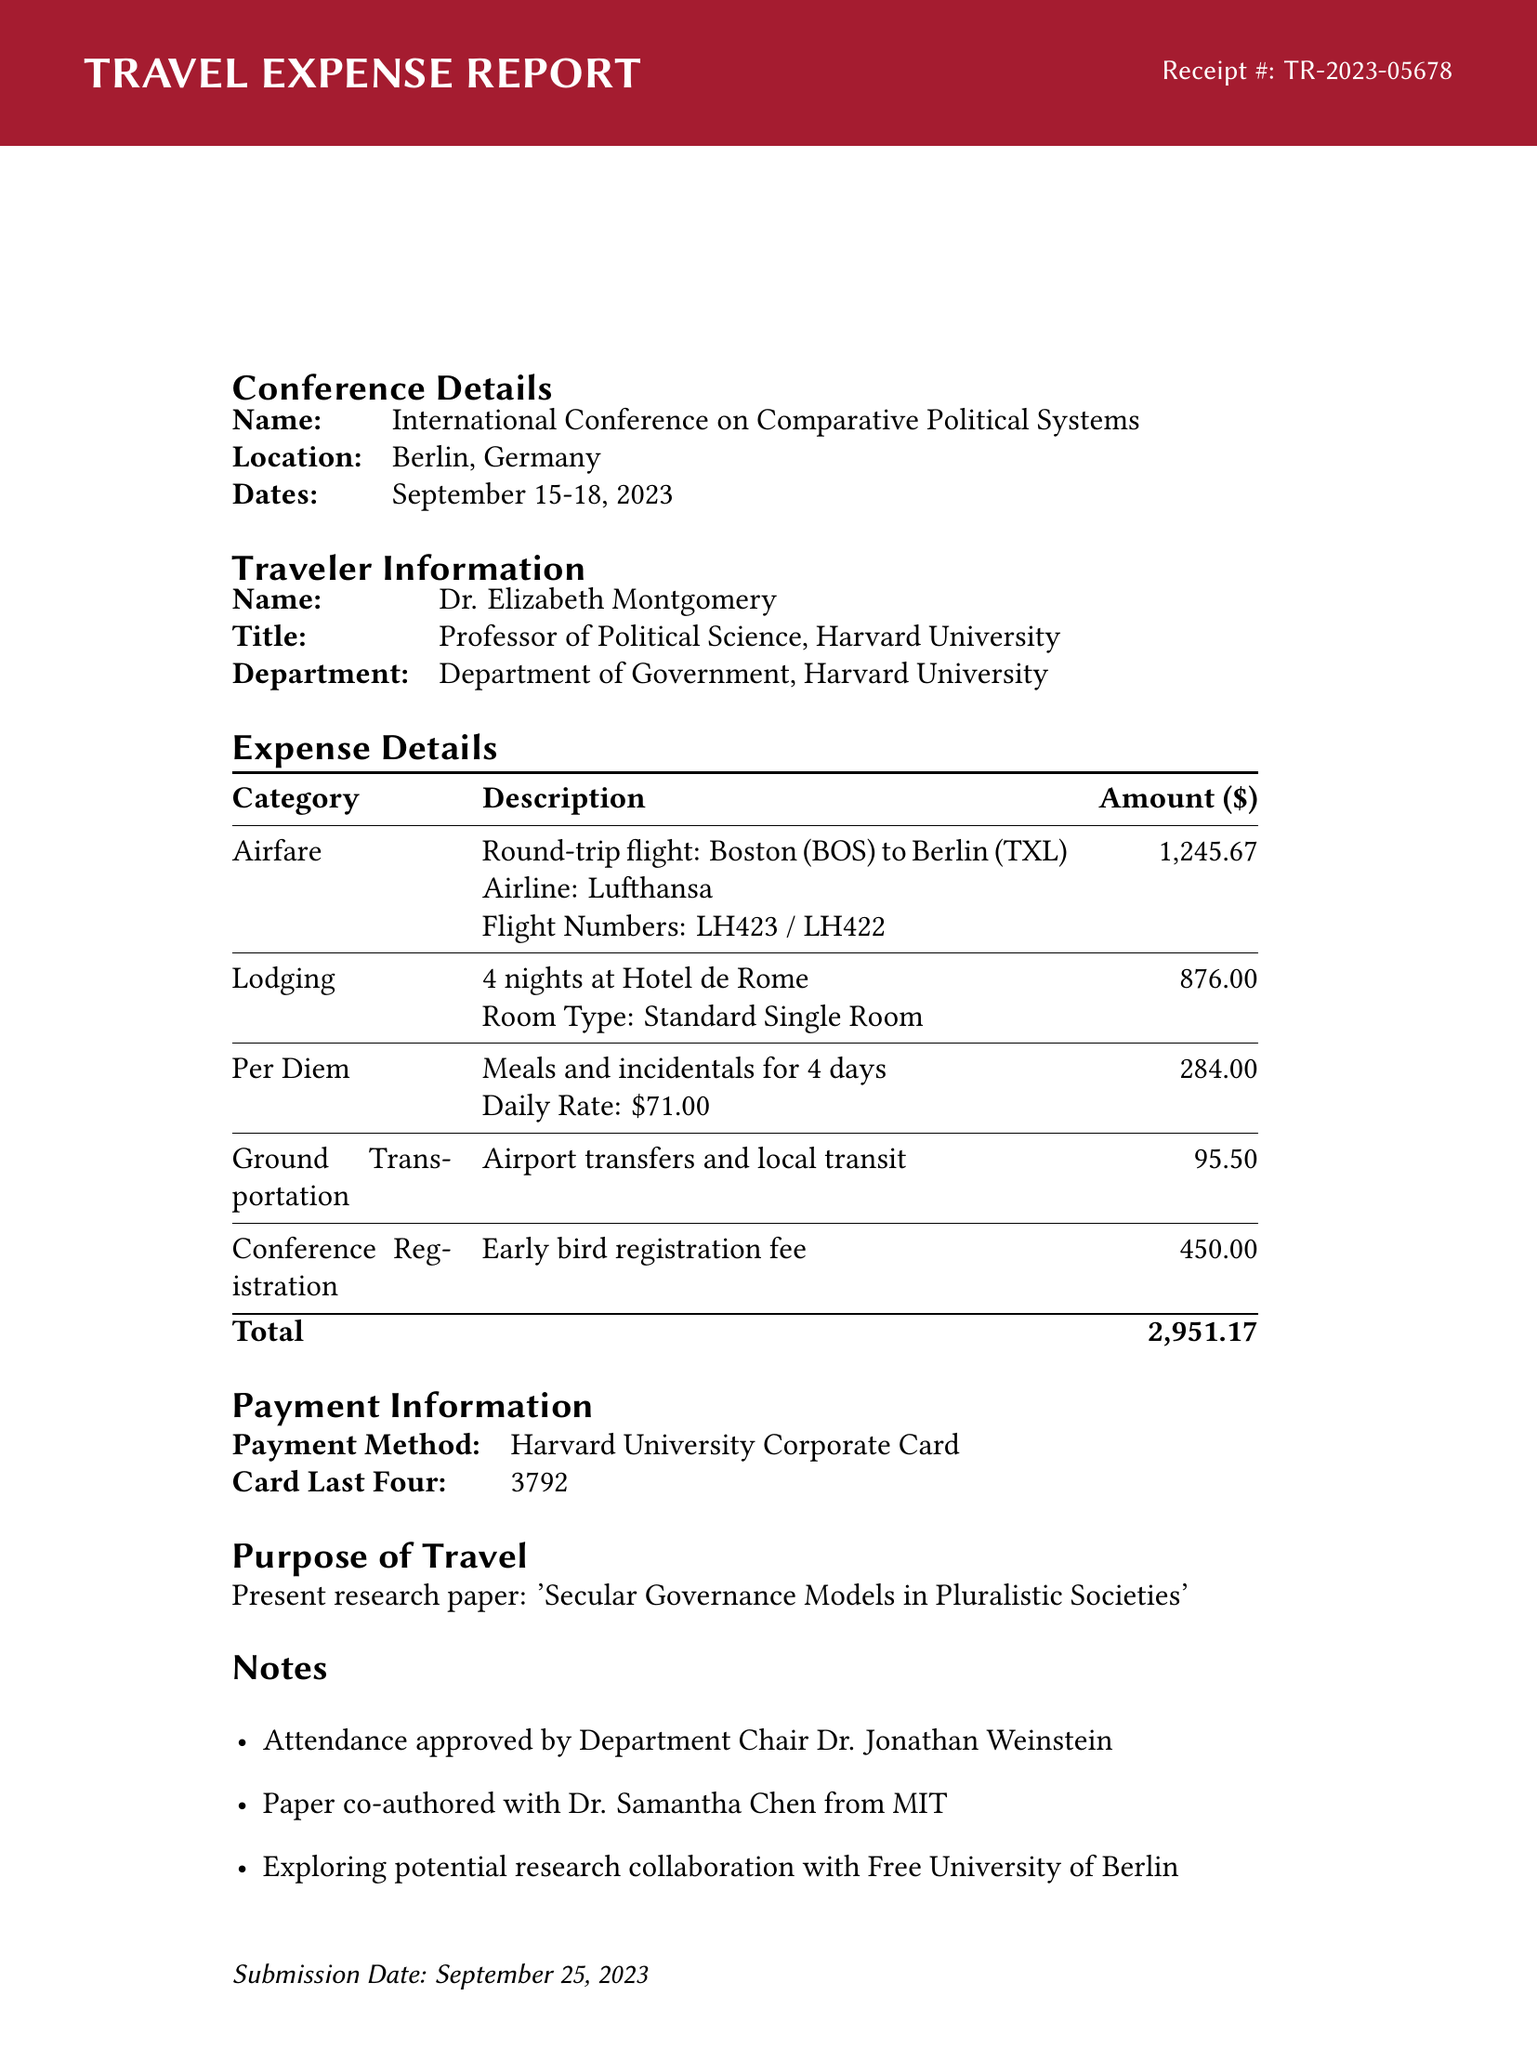What is the receipt number? The receipt number is clearly labeled in the document as a unique identifier for this expense report.
Answer: TR-2023-05678 What is the total amount of expenses? The total amount is summarized at the end of the expense details section, representing the cumulative costs incurred.
Answer: 2,951.17 Who is the traveler? The traveler is identified at the beginning of the traveler information section, providing their name and title.
Answer: Dr. Elizabeth Montgomery What was the purpose of travel? The purpose is explicitly stated in the document, summarizing the main objective of the trip.
Answer: Present research paper: 'Secular Governance Models in Pluralistic Societies' How many nights did the traveler stay at the hotel? The lodging expense details the number of nights that were booked for accommodation.
Answer: 4 nights What airline was used for the airfare? The airline information is included in the airfare expense section, detailing the service provider for the flight.
Answer: Lufthansa What was the daily per diem rate? The document specifies the daily rate of per diem allocated for meals and incidentals during the travel period.
Answer: 71.00 What is noted about the approval status of attendance? A specific note highlights the approval process for the travel attendance by a designated authority.
Answer: Attendance approved by Department Chair Dr. Jonathan Weinstein What is the category of the expense for airport transfers? The document categorizes expenses, and this specific category is specified in the ground transportation section.
Answer: Ground Transportation 